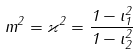Convert formula to latex. <formula><loc_0><loc_0><loc_500><loc_500>m ^ { 2 } = \varkappa ^ { 2 } = \frac { 1 - \iota _ { 1 } ^ { 2 } } { 1 - \iota _ { 2 } ^ { 2 } }</formula> 